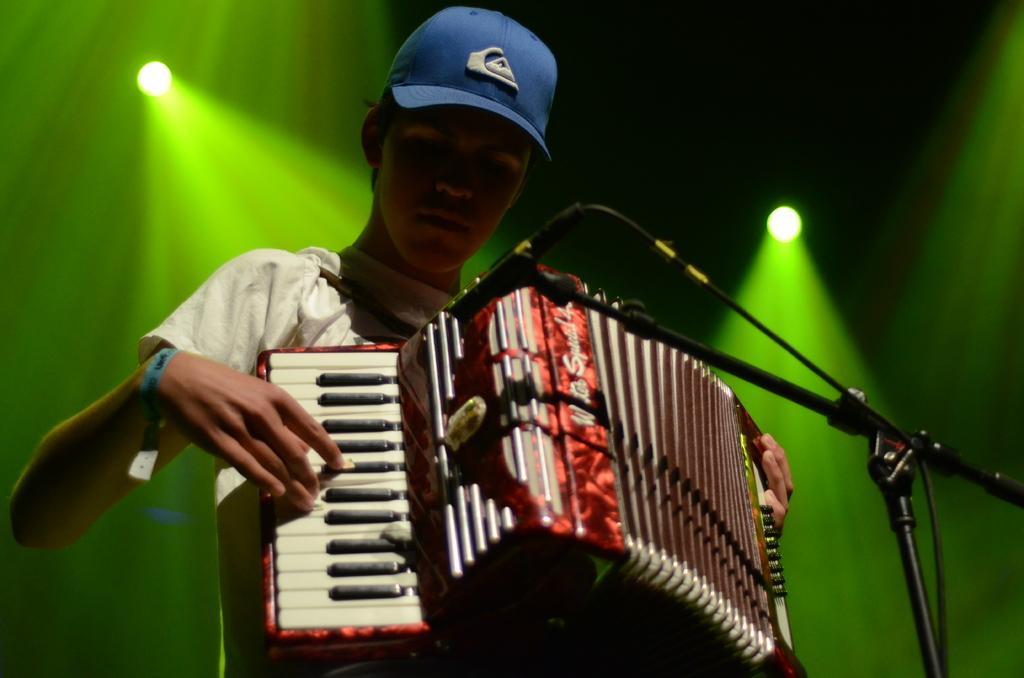Please provide a concise description of this image. As we can see in the image there is a man holding and playing musical instrument. 